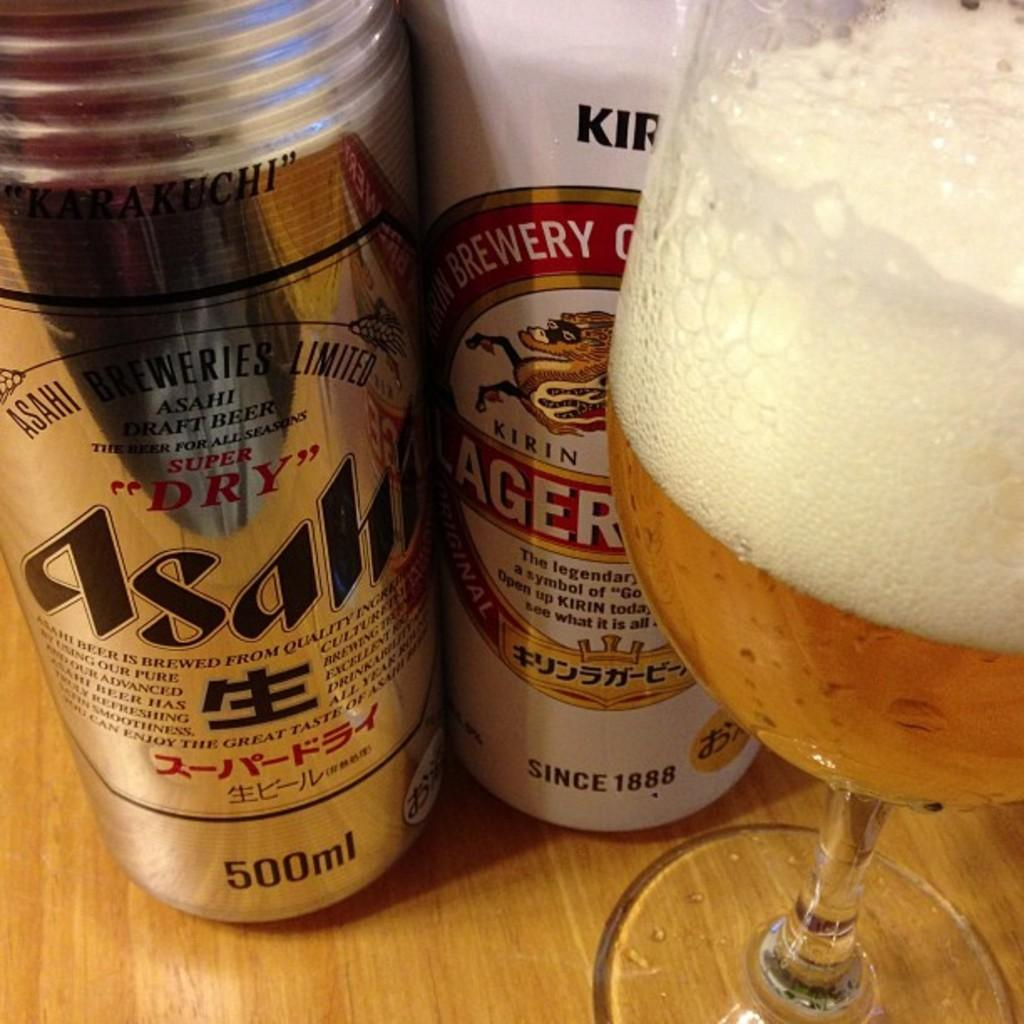<image>
Present a compact description of the photo's key features. Two cans of Japanese beer (Asahi and Kirin Ichiban), next to a half filled glass of beer. 